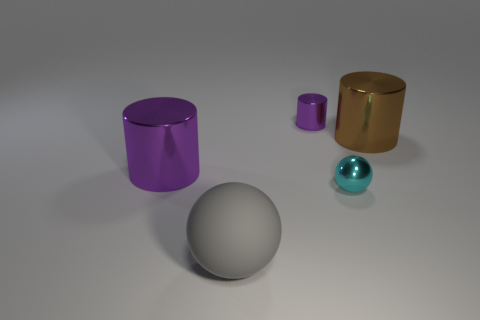Add 1 red cubes. How many objects exist? 6 Subtract all spheres. How many objects are left? 3 Subtract all large spheres. Subtract all small red rubber blocks. How many objects are left? 4 Add 2 cyan things. How many cyan things are left? 3 Add 1 tiny cyan metallic spheres. How many tiny cyan metallic spheres exist? 2 Subtract 1 purple cylinders. How many objects are left? 4 